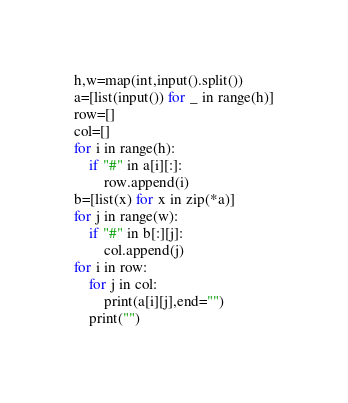Convert code to text. <code><loc_0><loc_0><loc_500><loc_500><_Python_>h,w=map(int,input().split())
a=[list(input()) for _ in range(h)]
row=[]
col=[]
for i in range(h):
    if "#" in a[i][:]:
        row.append(i)
b=[list(x) for x in zip(*a)]
for j in range(w):
    if "#" in b[:][j]:
        col.append(j)
for i in row:
    for j in col:
        print(a[i][j],end="")
    print("")</code> 